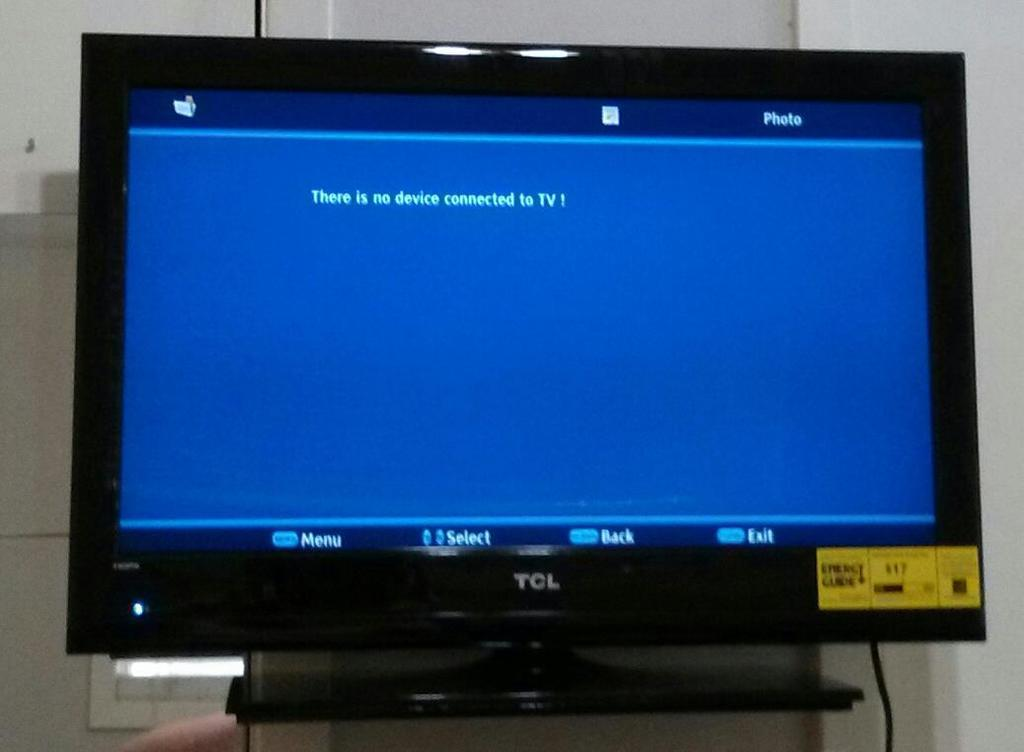<image>
Give a short and clear explanation of the subsequent image. A black VCL TV showing a blue screen that says there is no device connected to TV. 